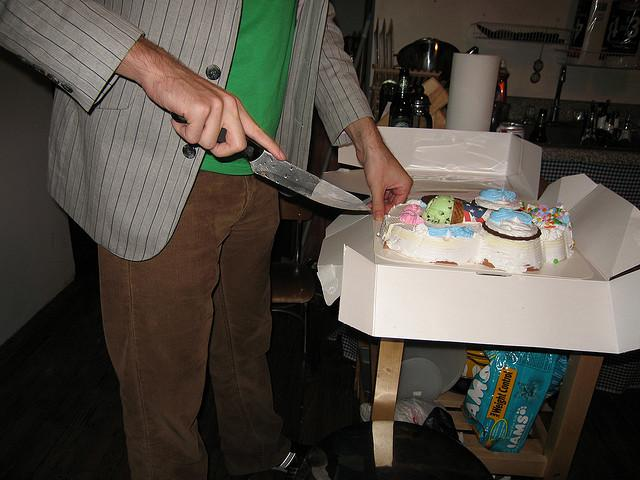What might be a major component of this treat?

Choices:
A) carrots
B) muffins
C) ice cream
D) raisins ice cream 